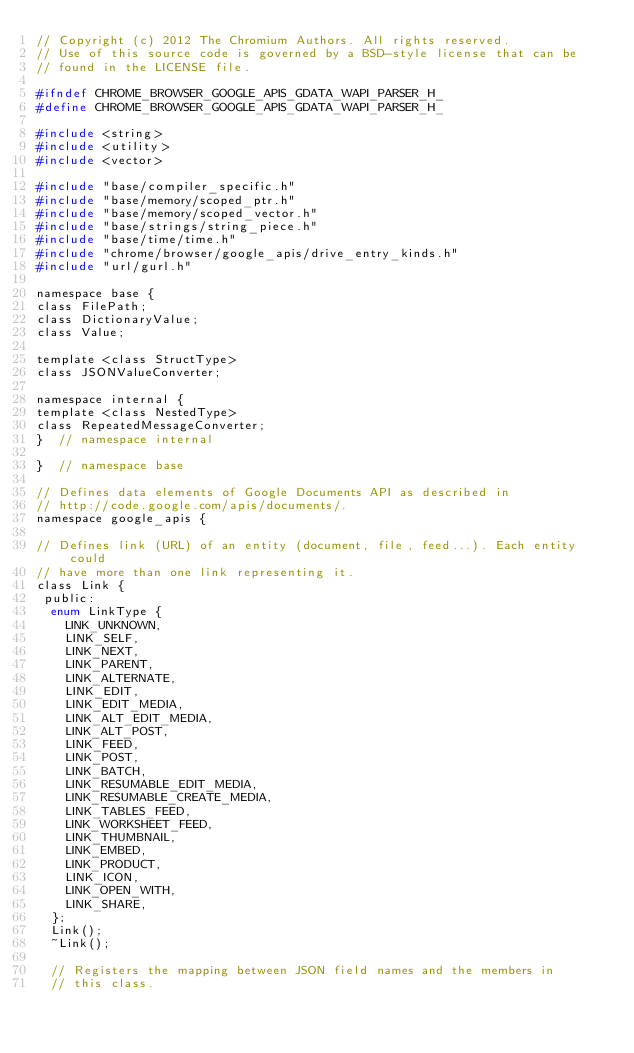Convert code to text. <code><loc_0><loc_0><loc_500><loc_500><_C_>// Copyright (c) 2012 The Chromium Authors. All rights reserved.
// Use of this source code is governed by a BSD-style license that can be
// found in the LICENSE file.

#ifndef CHROME_BROWSER_GOOGLE_APIS_GDATA_WAPI_PARSER_H_
#define CHROME_BROWSER_GOOGLE_APIS_GDATA_WAPI_PARSER_H_

#include <string>
#include <utility>
#include <vector>

#include "base/compiler_specific.h"
#include "base/memory/scoped_ptr.h"
#include "base/memory/scoped_vector.h"
#include "base/strings/string_piece.h"
#include "base/time/time.h"
#include "chrome/browser/google_apis/drive_entry_kinds.h"
#include "url/gurl.h"

namespace base {
class FilePath;
class DictionaryValue;
class Value;

template <class StructType>
class JSONValueConverter;

namespace internal {
template <class NestedType>
class RepeatedMessageConverter;
}  // namespace internal

}  // namespace base

// Defines data elements of Google Documents API as described in
// http://code.google.com/apis/documents/.
namespace google_apis {

// Defines link (URL) of an entity (document, file, feed...). Each entity could
// have more than one link representing it.
class Link {
 public:
  enum LinkType {
    LINK_UNKNOWN,
    LINK_SELF,
    LINK_NEXT,
    LINK_PARENT,
    LINK_ALTERNATE,
    LINK_EDIT,
    LINK_EDIT_MEDIA,
    LINK_ALT_EDIT_MEDIA,
    LINK_ALT_POST,
    LINK_FEED,
    LINK_POST,
    LINK_BATCH,
    LINK_RESUMABLE_EDIT_MEDIA,
    LINK_RESUMABLE_CREATE_MEDIA,
    LINK_TABLES_FEED,
    LINK_WORKSHEET_FEED,
    LINK_THUMBNAIL,
    LINK_EMBED,
    LINK_PRODUCT,
    LINK_ICON,
    LINK_OPEN_WITH,
    LINK_SHARE,
  };
  Link();
  ~Link();

  // Registers the mapping between JSON field names and the members in
  // this class.</code> 